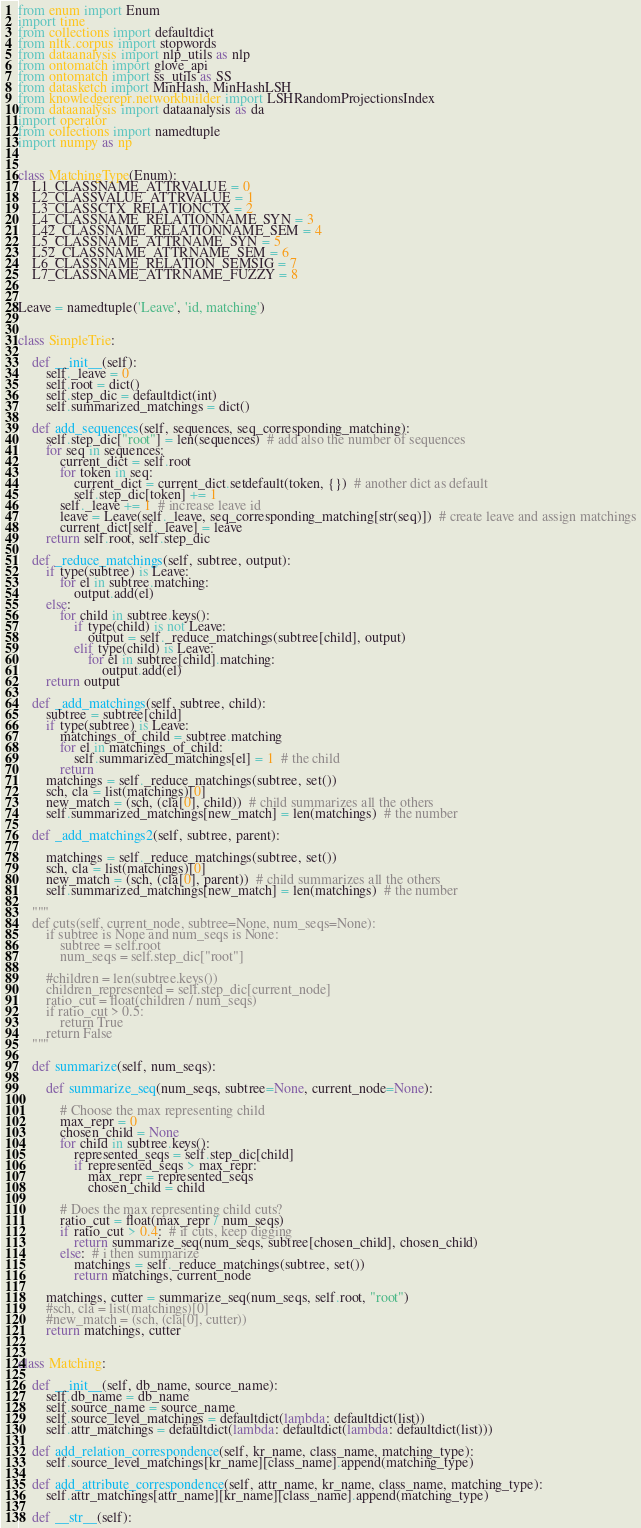<code> <loc_0><loc_0><loc_500><loc_500><_Python_>from enum import Enum
import time
from collections import defaultdict
from nltk.corpus import stopwords
from dataanalysis import nlp_utils as nlp
from ontomatch import glove_api
from ontomatch import ss_utils as SS
from datasketch import MinHash, MinHashLSH
from knowledgerepr.networkbuilder import LSHRandomProjectionsIndex
from dataanalysis import dataanalysis as da
import operator
from collections import namedtuple
import numpy as np


class MatchingType(Enum):
    L1_CLASSNAME_ATTRVALUE = 0
    L2_CLASSVALUE_ATTRVALUE = 1
    L3_CLASSCTX_RELATIONCTX = 2
    L4_CLASSNAME_RELATIONNAME_SYN = 3
    L42_CLASSNAME_RELATIONNAME_SEM = 4
    L5_CLASSNAME_ATTRNAME_SYN = 5
    L52_CLASSNAME_ATTRNAME_SEM = 6
    L6_CLASSNAME_RELATION_SEMSIG = 7
    L7_CLASSNAME_ATTRNAME_FUZZY = 8


Leave = namedtuple('Leave', 'id, matching')


class SimpleTrie:

    def __init__(self):
        self._leave = 0
        self.root = dict()
        self.step_dic = defaultdict(int)
        self.summarized_matchings = dict()

    def add_sequences(self, sequences, seq_corresponding_matching):
        self.step_dic["root"] = len(sequences)  # add also the number of sequences
        for seq in sequences:
            current_dict = self.root
            for token in seq:
                current_dict = current_dict.setdefault(token, {})  # another dict as default
                self.step_dic[token] += 1
            self._leave += 1  # increase leave id
            leave = Leave(self._leave, seq_corresponding_matching[str(seq)])  # create leave and assign matchings
            current_dict[self._leave] = leave
        return self.root, self.step_dic

    def _reduce_matchings(self, subtree, output):
        if type(subtree) is Leave:
            for el in subtree.matching:
                output.add(el)
        else:
            for child in subtree.keys():
                if type(child) is not Leave:
                    output = self._reduce_matchings(subtree[child], output)
                elif type(child) is Leave:
                    for el in subtree[child].matching:
                        output.add(el)
        return output

    def _add_matchings(self, subtree, child):
        subtree = subtree[child]
        if type(subtree) is Leave:
            matchings_of_child = subtree.matching
            for el in matchings_of_child:
                self.summarized_matchings[el] = 1  # the child
            return
        matchings = self._reduce_matchings(subtree, set())
        sch, cla = list(matchings)[0]
        new_match = (sch, (cla[0], child))  # child summarizes all the others
        self.summarized_matchings[new_match] = len(matchings)  # the number

    def _add_matchings2(self, subtree, parent):

        matchings = self._reduce_matchings(subtree, set())
        sch, cla = list(matchings)[0]
        new_match = (sch, (cla[0], parent))  # child summarizes all the others
        self.summarized_matchings[new_match] = len(matchings)  # the number

    """
    def cuts(self, current_node, subtree=None, num_seqs=None):
        if subtree is None and num_seqs is None:
            subtree = self.root
            num_seqs = self.step_dic["root"]

        #children = len(subtree.keys())
        children_represented = self.step_dic[current_node]
        ratio_cut = float(children / num_seqs)
        if ratio_cut > 0.5:
            return True
        return False
    """

    def summarize(self, num_seqs):

        def summarize_seq(num_seqs, subtree=None, current_node=None):

            # Choose the max representing child
            max_repr = 0
            chosen_child = None
            for child in subtree.keys():
                represented_seqs = self.step_dic[child]
                if represented_seqs > max_repr:
                    max_repr = represented_seqs
                    chosen_child = child

            # Does the max representing child cuts?
            ratio_cut = float(max_repr / num_seqs)
            if ratio_cut > 0.4:  # if cuts, keep digging
                return summarize_seq(num_seqs, subtree[chosen_child], chosen_child)
            else:  # i then summarize
                matchings = self._reduce_matchings(subtree, set())
                return matchings, current_node

        matchings, cutter = summarize_seq(num_seqs, self.root, "root")
        #sch, cla = list(matchings)[0]
        #new_match = (sch, (cla[0], cutter))
        return matchings, cutter


class Matching:

    def __init__(self, db_name, source_name):
        self.db_name = db_name
        self.source_name = source_name
        self.source_level_matchings = defaultdict(lambda: defaultdict(list))
        self.attr_matchings = defaultdict(lambda: defaultdict(lambda: defaultdict(list)))

    def add_relation_correspondence(self, kr_name, class_name, matching_type):
        self.source_level_matchings[kr_name][class_name].append(matching_type)

    def add_attribute_correspondence(self, attr_name, kr_name, class_name, matching_type):
        self.attr_matchings[attr_name][kr_name][class_name].append(matching_type)

    def __str__(self):</code> 